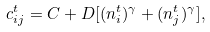Convert formula to latex. <formula><loc_0><loc_0><loc_500><loc_500>c ^ { t } _ { i j } = C + D [ ( n ^ { t } _ { i } ) ^ { \gamma } + ( n ^ { t } _ { j } ) ^ { \gamma } ] ,</formula> 